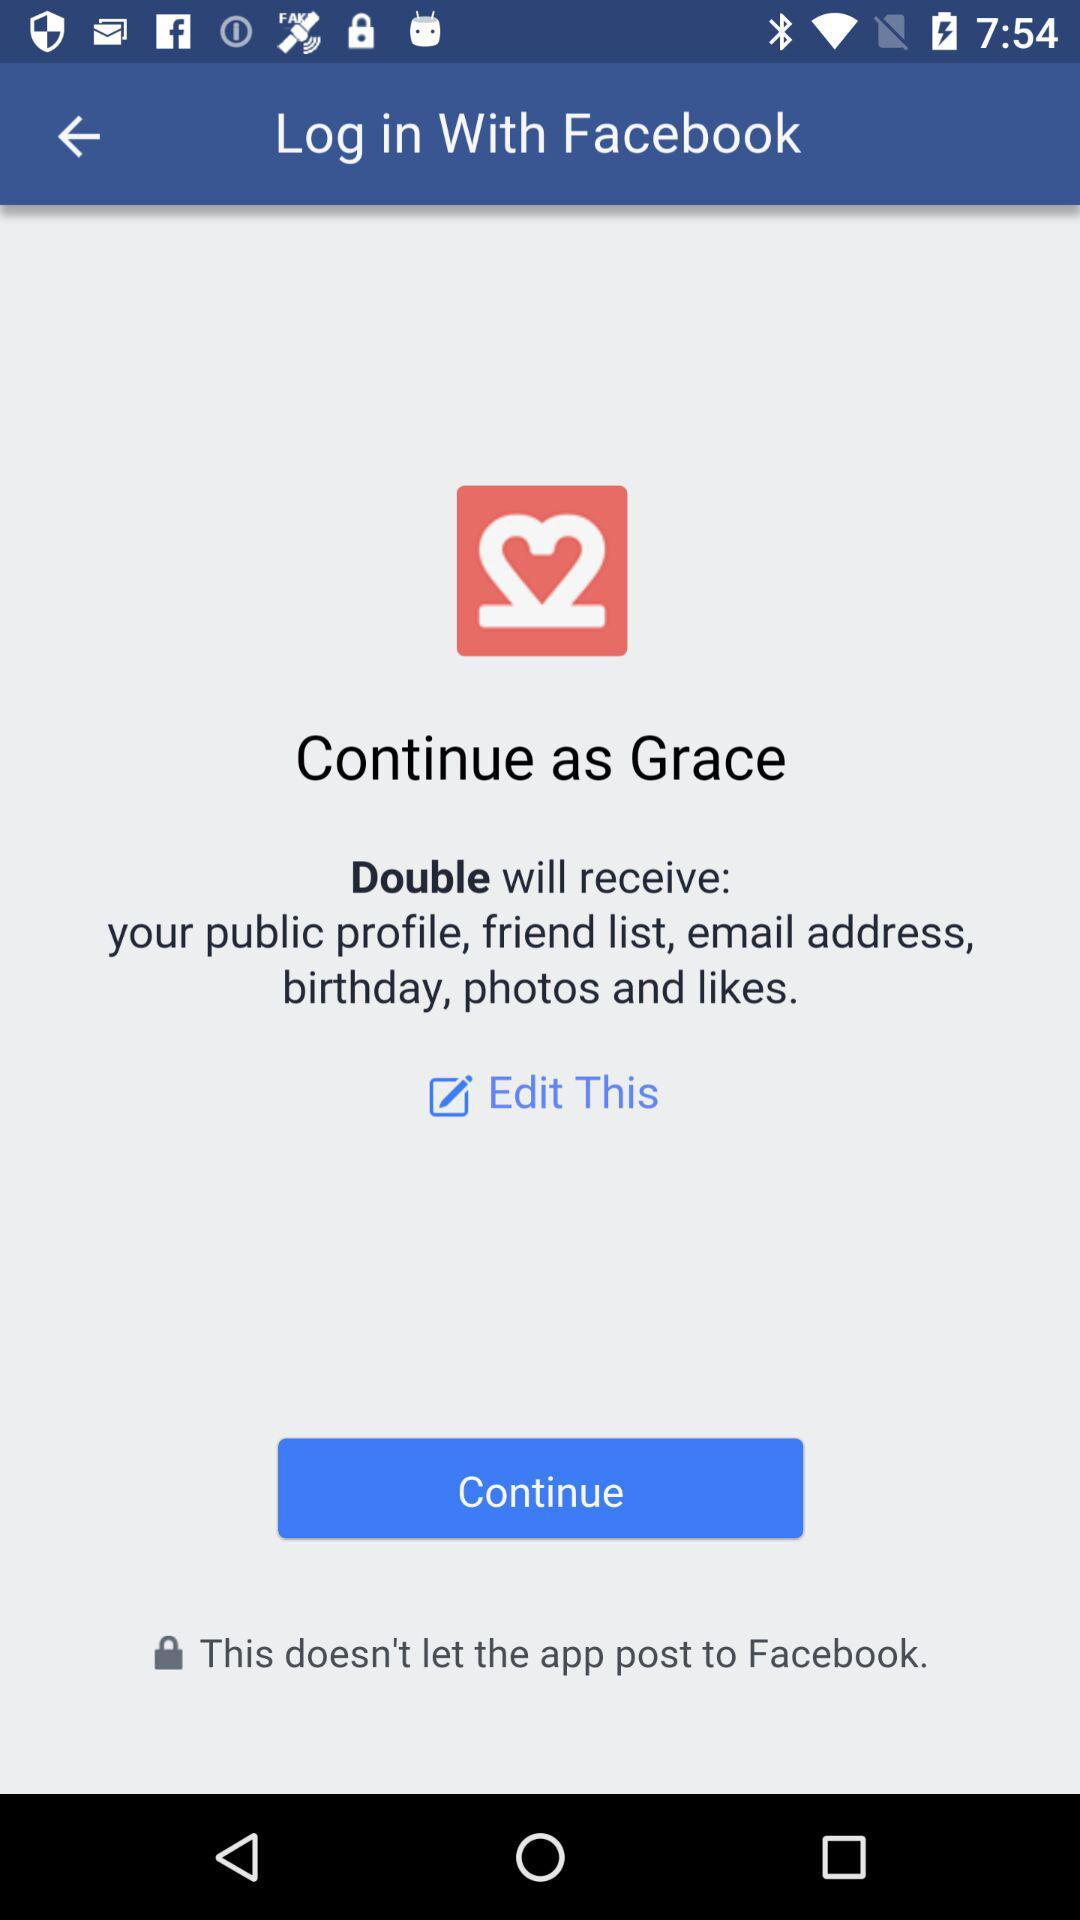What is the name of the user? The name of the user is Grace. 